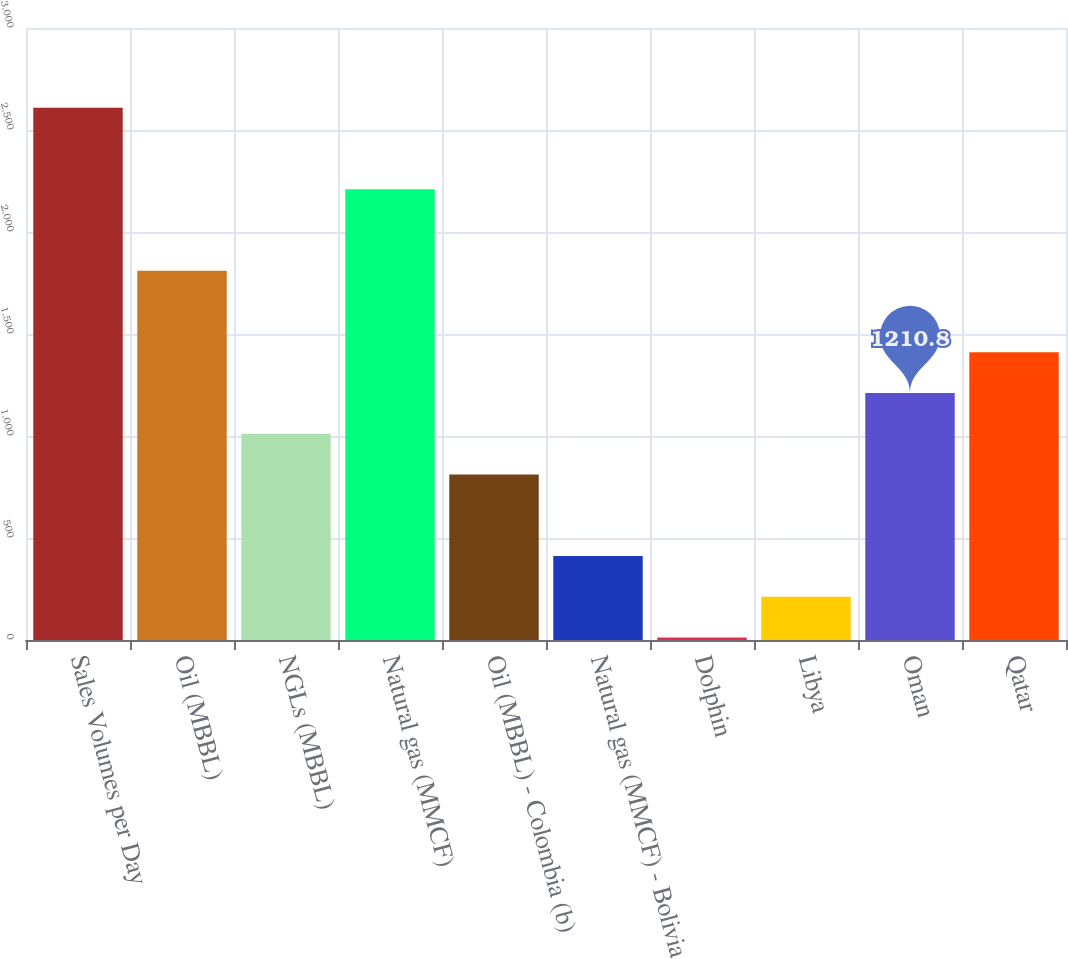Convert chart. <chart><loc_0><loc_0><loc_500><loc_500><bar_chart><fcel>Sales Volumes per Day<fcel>Oil (MBBL)<fcel>NGLs (MBBL)<fcel>Natural gas (MMCF)<fcel>Oil (MBBL) - Colombia (b)<fcel>Natural gas (MMCF) - Bolivia<fcel>Dolphin<fcel>Libya<fcel>Oman<fcel>Qatar<nl><fcel>2609.4<fcel>1810.2<fcel>1011<fcel>2209.8<fcel>811.2<fcel>411.6<fcel>12<fcel>211.8<fcel>1210.8<fcel>1410.6<nl></chart> 